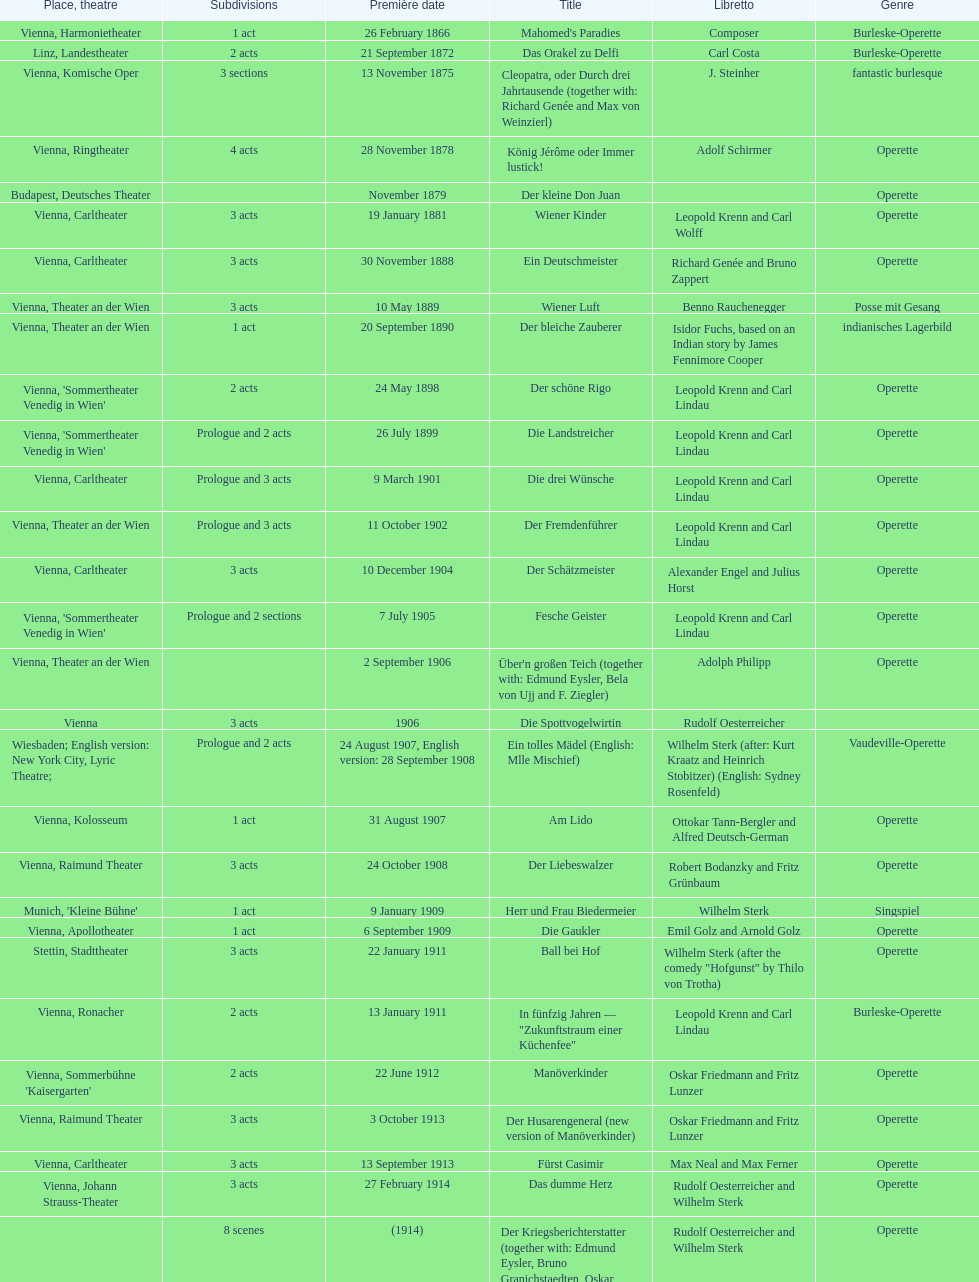Can you give me this table as a dict? {'header': ['Place, theatre', 'Sub\xaddivisions', 'Première date', 'Title', 'Libretto', 'Genre'], 'rows': [['Vienna, Harmonietheater', '1 act', '26 February 1866', "Mahomed's Paradies", 'Composer', 'Burleske-Operette'], ['Linz, Landestheater', '2 acts', '21 September 1872', 'Das Orakel zu Delfi', 'Carl Costa', 'Burleske-Operette'], ['Vienna, Komische Oper', '3 sections', '13 November 1875', 'Cleopatra, oder Durch drei Jahrtausende (together with: Richard Genée and Max von Weinzierl)', 'J. Steinher', 'fantastic burlesque'], ['Vienna, Ringtheater', '4 acts', '28 November 1878', 'König Jérôme oder Immer lustick!', 'Adolf Schirmer', 'Operette'], ['Budapest, Deutsches Theater', '', 'November 1879', 'Der kleine Don Juan', '', 'Operette'], ['Vienna, Carltheater', '3 acts', '19 January 1881', 'Wiener Kinder', 'Leopold Krenn and Carl Wolff', 'Operette'], ['Vienna, Carltheater', '3 acts', '30 November 1888', 'Ein Deutschmeister', 'Richard Genée and Bruno Zappert', 'Operette'], ['Vienna, Theater an der Wien', '3 acts', '10 May 1889', 'Wiener Luft', 'Benno Rauchenegger', 'Posse mit Gesang'], ['Vienna, Theater an der Wien', '1 act', '20 September 1890', 'Der bleiche Zauberer', 'Isidor Fuchs, based on an Indian story by James Fennimore Cooper', 'indianisches Lagerbild'], ["Vienna, 'Sommertheater Venedig in Wien'", '2 acts', '24 May 1898', 'Der schöne Rigo', 'Leopold Krenn and Carl Lindau', 'Operette'], ["Vienna, 'Sommertheater Venedig in Wien'", 'Prologue and 2 acts', '26 July 1899', 'Die Landstreicher', 'Leopold Krenn and Carl Lindau', 'Operette'], ['Vienna, Carltheater', 'Prologue and 3 acts', '9 March 1901', 'Die drei Wünsche', 'Leopold Krenn and Carl Lindau', 'Operette'], ['Vienna, Theater an der Wien', 'Prologue and 3 acts', '11 October 1902', 'Der Fremdenführer', 'Leopold Krenn and Carl Lindau', 'Operette'], ['Vienna, Carltheater', '3 acts', '10 December 1904', 'Der Schätzmeister', 'Alexander Engel and Julius Horst', 'Operette'], ["Vienna, 'Sommertheater Venedig in Wien'", 'Prologue and 2 sections', '7 July 1905', 'Fesche Geister', 'Leopold Krenn and Carl Lindau', 'Operette'], ['Vienna, Theater an der Wien', '', '2 September 1906', "Über'n großen Teich (together with: Edmund Eysler, Bela von Ujj and F. Ziegler)", 'Adolph Philipp', 'Operette'], ['Vienna', '3 acts', '1906', 'Die Spottvogelwirtin', 'Rudolf Oesterreicher', ''], ['Wiesbaden; English version: New York City, Lyric Theatre;', 'Prologue and 2 acts', '24 August 1907, English version: 28 September 1908', 'Ein tolles Mädel (English: Mlle Mischief)', 'Wilhelm Sterk (after: Kurt Kraatz and Heinrich Stobitzer) (English: Sydney Rosenfeld)', 'Vaudeville-Operette'], ['Vienna, Kolosseum', '1 act', '31 August 1907', 'Am Lido', 'Ottokar Tann-Bergler and Alfred Deutsch-German', 'Operette'], ['Vienna, Raimund Theater', '3 acts', '24 October 1908', 'Der Liebeswalzer', 'Robert Bodanzky and Fritz Grünbaum', 'Operette'], ["Munich, 'Kleine Bühne'", '1 act', '9 January 1909', 'Herr und Frau Biedermeier', 'Wilhelm Sterk', 'Singspiel'], ['Vienna, Apollotheater', '1 act', '6 September 1909', 'Die Gaukler', 'Emil Golz and Arnold Golz', 'Operette'], ['Stettin, Stadttheater', '3 acts', '22 January 1911', 'Ball bei Hof', 'Wilhelm Sterk (after the comedy "Hofgunst" by Thilo von Trotha)', 'Operette'], ['Vienna, Ronacher', '2 acts', '13 January 1911', 'In fünfzig Jahren — "Zukunftstraum einer Küchenfee"', 'Leopold Krenn and Carl Lindau', 'Burleske-Operette'], ["Vienna, Sommerbühne 'Kaisergarten'", '2 acts', '22 June 1912', 'Manöverkinder', 'Oskar Friedmann and Fritz Lunzer', 'Operette'], ['Vienna, Raimund Theater', '3 acts', '3 October 1913', 'Der Husarengeneral (new version of Manöverkinder)', 'Oskar Friedmann and Fritz Lunzer', 'Operette'], ['Vienna, Carltheater', '3 acts', '13 September 1913', 'Fürst Casimir', 'Max Neal and Max Ferner', 'Operette'], ['Vienna, Johann Strauss-Theater', '3 acts', '27 February 1914', 'Das dumme Herz', 'Rudolf Oesterreicher and Wilhelm Sterk', 'Operette'], ['', '8 scenes', '(1914)', 'Der Kriegsberichterstatter (together with: Edmund Eysler, Bruno Granichstaedten, Oskar Nedbal, Charles Weinberger)', 'Rudolf Oesterreicher and Wilhelm Sterk', 'Operette'], ['Munich, Theater am Gärtnerplatz', '3 acts', '26 February 1916', 'Im siebenten Himmel', 'Max Neal and Max Ferner', 'Operette'], ['Vienna, Raimund Theater', '', '30 May 1958', 'Deutschmeisterkapelle', 'Hubert Marischka and Rudolf Oesterreicher', 'Operette'], ['Vienna, Johann-Strauß-Theater', '3 acts', '11 July 1930', 'Die verliebte Eskadron', 'Wilhelm Sterk (after B. Buchbinder)', 'Operette']]} How many number of 1 acts were there? 5. 